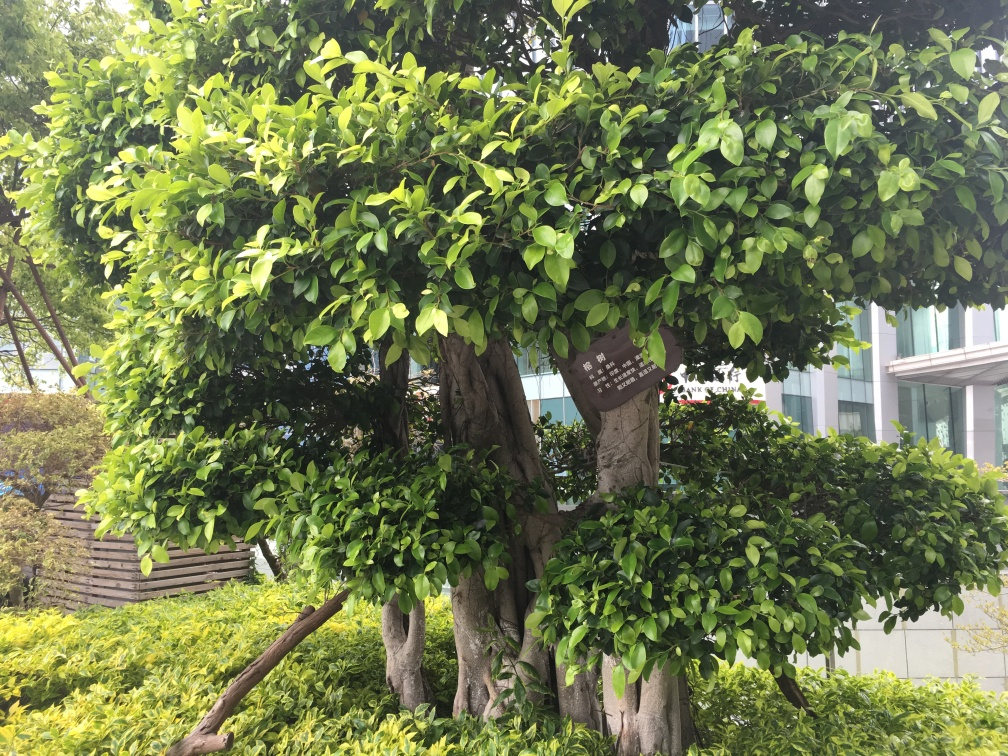What can we infer about the location of this image? The well-maintained shrubbery and orderly arrangement of plants suggest a landscaped area, perhaps part of a park, corporate campus, or public garden. The presence of a multi-story building in the background with reflective windows indicates an urban or suburban setting. 